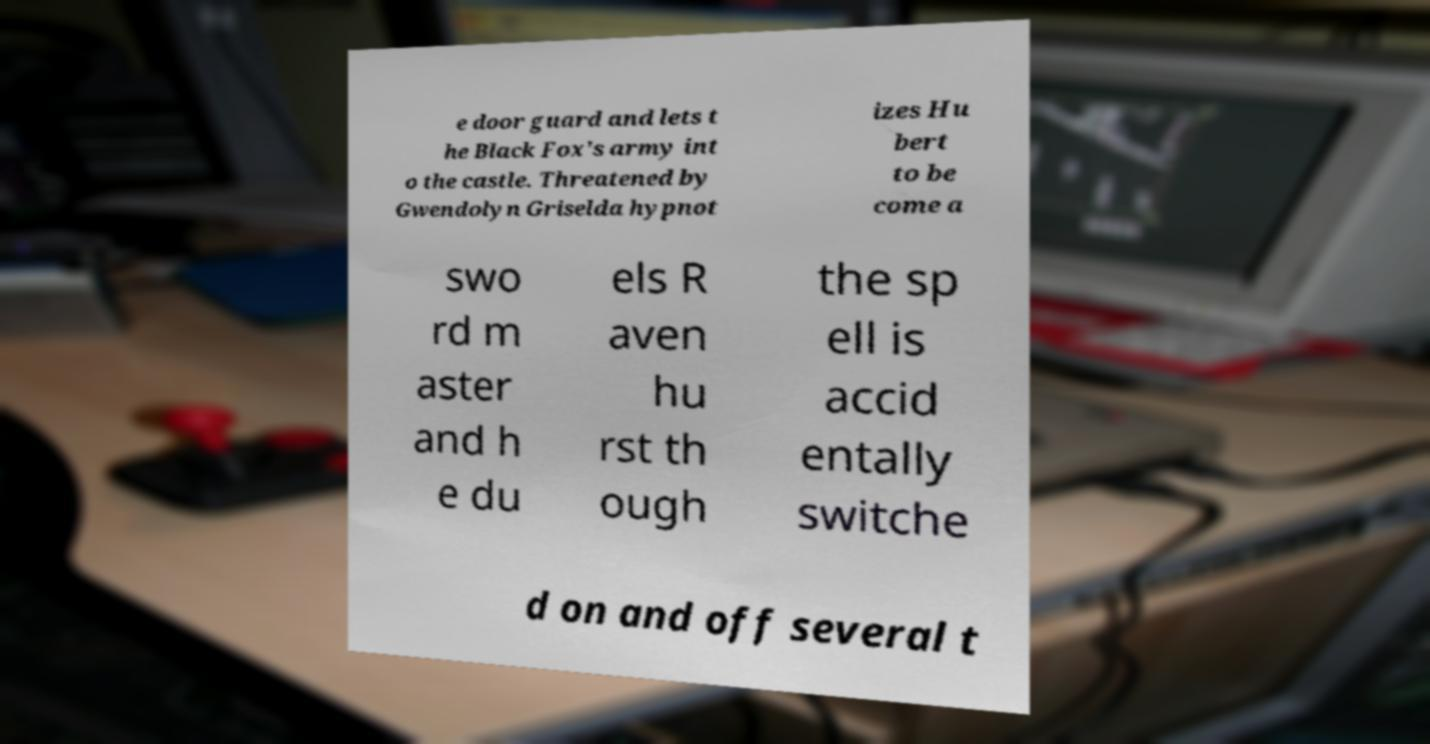Could you extract and type out the text from this image? e door guard and lets t he Black Fox's army int o the castle. Threatened by Gwendolyn Griselda hypnot izes Hu bert to be come a swo rd m aster and h e du els R aven hu rst th ough the sp ell is accid entally switche d on and off several t 